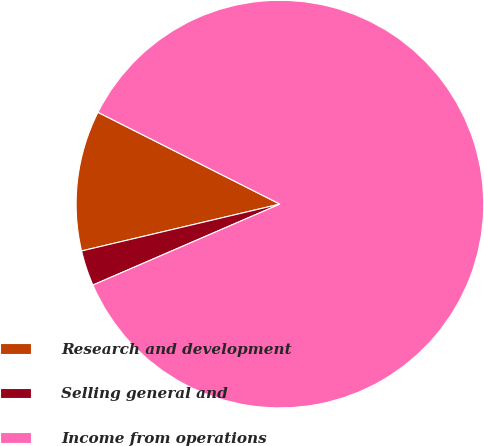<chart> <loc_0><loc_0><loc_500><loc_500><pie_chart><fcel>Research and development<fcel>Selling general and<fcel>Income from operations<nl><fcel>11.13%<fcel>2.81%<fcel>86.06%<nl></chart> 